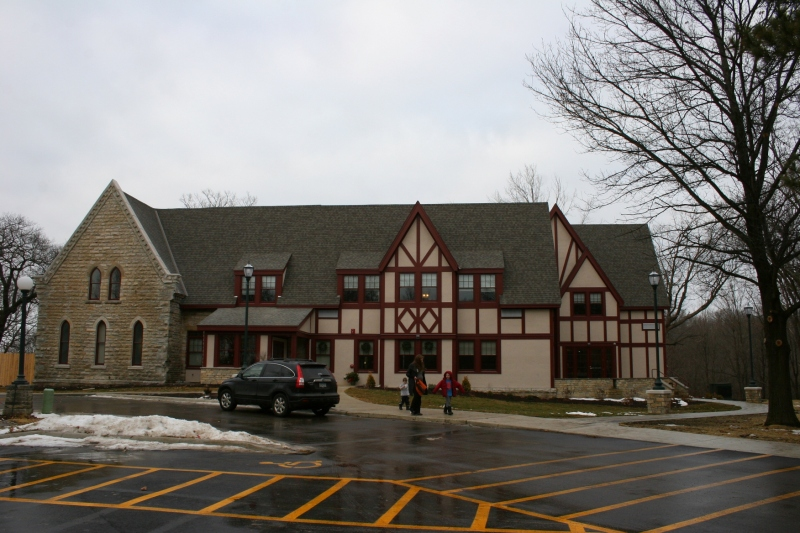What could be the function of this building based on its architectural features and the presence of the pedestrian crossing? The building in the image features a harmonious blend of traditional stone construction and timber-framed segments, suggesting a structure with historical roots adapted for modern use. The presence of a prominently marked pedestrian crossing directly in front of it further implies its role as a facility frequently accessed by the public, likely serving as a community center, place of worship, or a local museum. Such a design, combining both accessibility and aesthetic appeal, is typically aimed at welcoming a diverse group of visitors, enhancing its role as a key node in community life. 